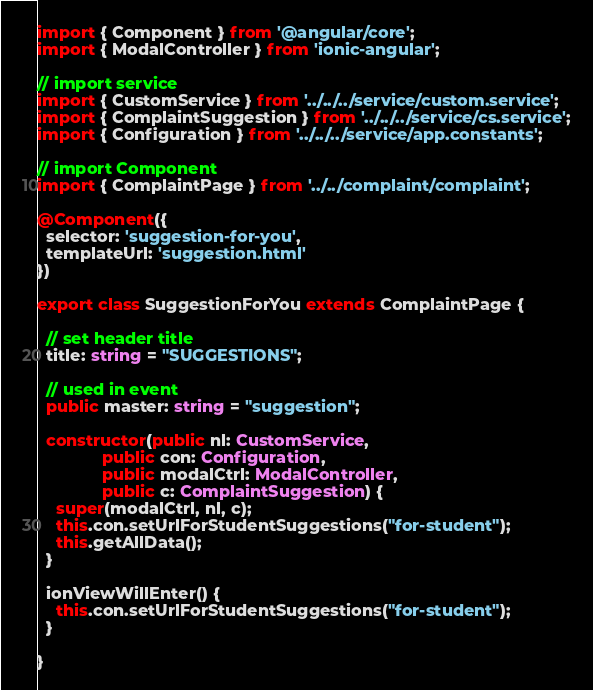Convert code to text. <code><loc_0><loc_0><loc_500><loc_500><_TypeScript_>import { Component } from '@angular/core';
import { ModalController } from 'ionic-angular';

// import service
import { CustomService } from '../../../service/custom.service';
import { ComplaintSuggestion } from '../../../service/cs.service';
import { Configuration } from '../../../service/app.constants';

// import Component
import { ComplaintPage } from '../../complaint/complaint';

@Component({
  selector: 'suggestion-for-you',
  templateUrl: 'suggestion.html'
})

export class SuggestionForYou extends ComplaintPage {

  // set header title
  title: string = "SUGGESTIONS";

  // used in event
  public master: string = "suggestion";

  constructor(public nl: CustomService,
              public con: Configuration,
              public modalCtrl: ModalController,
              public c: ComplaintSuggestion) {
    super(modalCtrl, nl, c);
    this.con.setUrlForStudentSuggestions("for-student");
    this.getAllData();
  }

  ionViewWillEnter() {
    this.con.setUrlForStudentSuggestions("for-student");
  }

}
</code> 